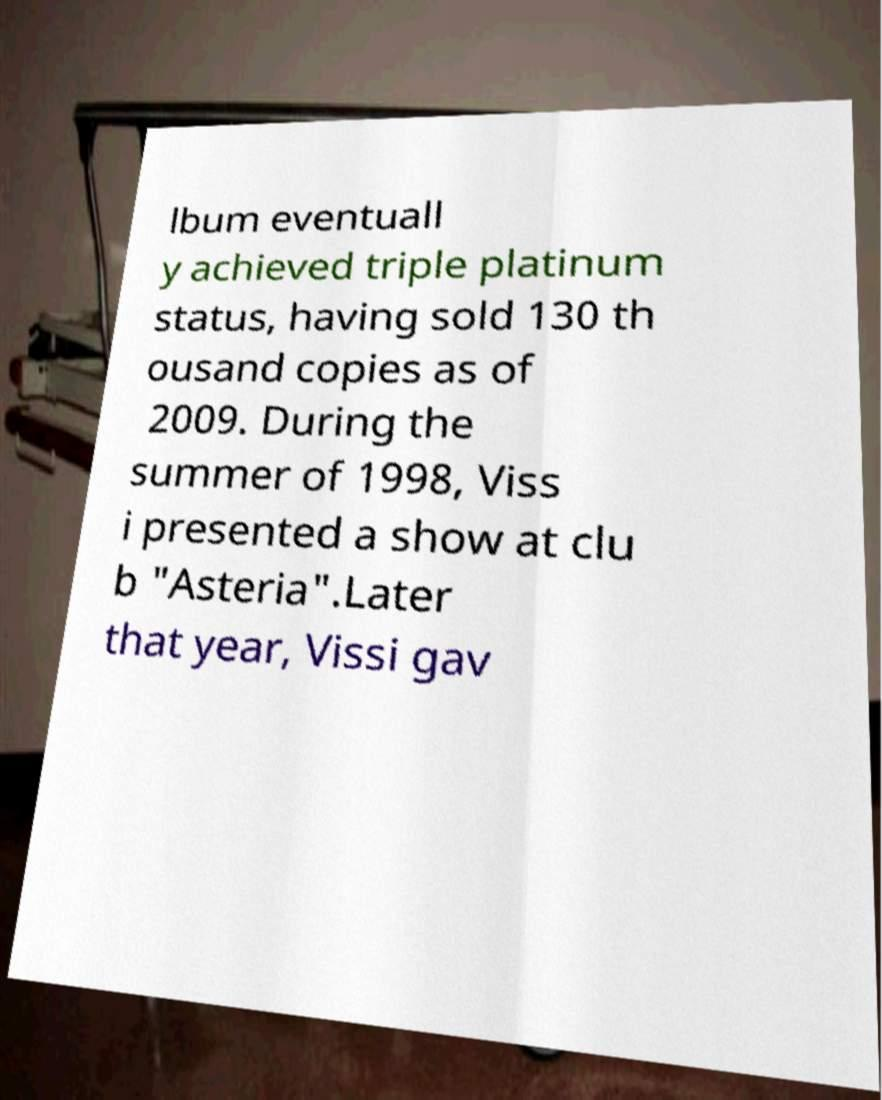Can you accurately transcribe the text from the provided image for me? lbum eventuall y achieved triple platinum status, having sold 130 th ousand copies as of 2009. During the summer of 1998, Viss i presented a show at clu b "Asteria".Later that year, Vissi gav 